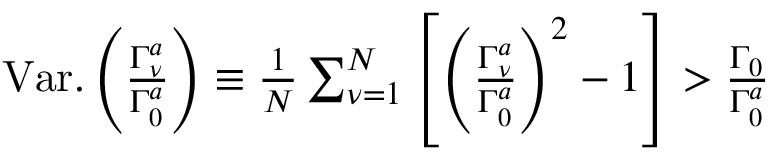Convert formula to latex. <formula><loc_0><loc_0><loc_500><loc_500>\begin{array} { r } { V a r . \left ( \frac { \Gamma _ { \nu } ^ { a } } { \Gamma _ { 0 } ^ { a } } \right ) \equiv \frac { 1 } { N } \sum _ { \nu = 1 } ^ { N } \left [ \left ( \frac { \Gamma _ { \nu } ^ { a } } { \Gamma _ { 0 } ^ { a } } \right ) ^ { 2 } - 1 \right ] > \frac { \Gamma _ { 0 } } { \Gamma _ { 0 } ^ { a } } } \end{array}</formula> 